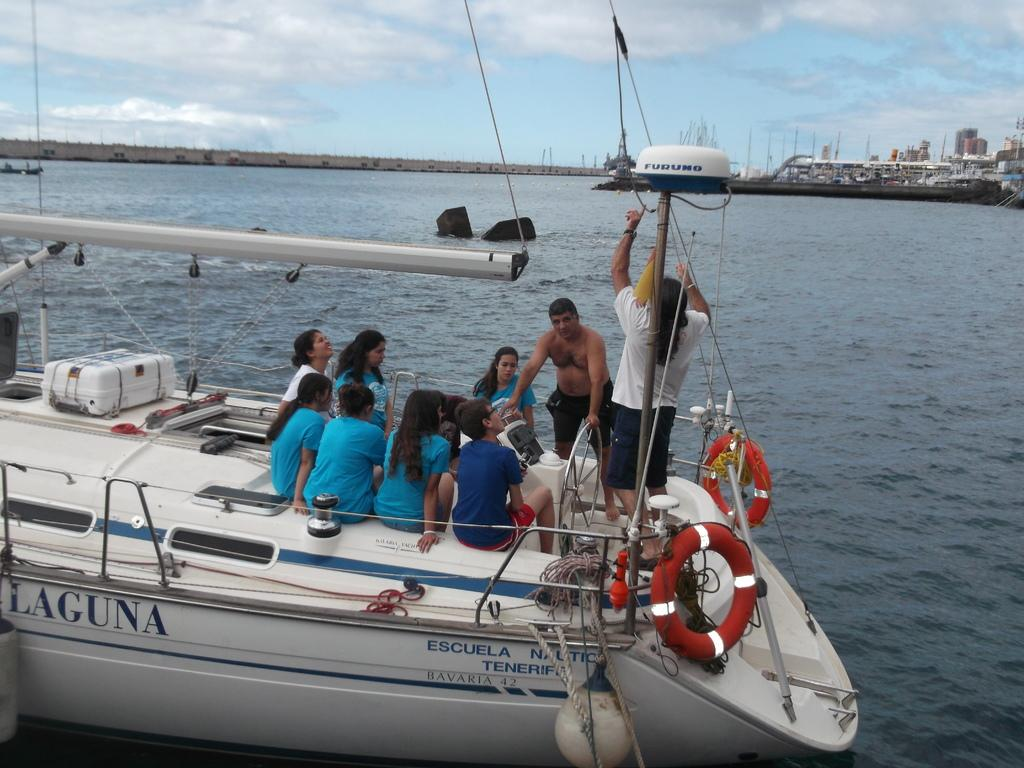<image>
Relay a brief, clear account of the picture shown. A group of people wearing blue shirts are sitting on the back of a sailboat named "laguna" 